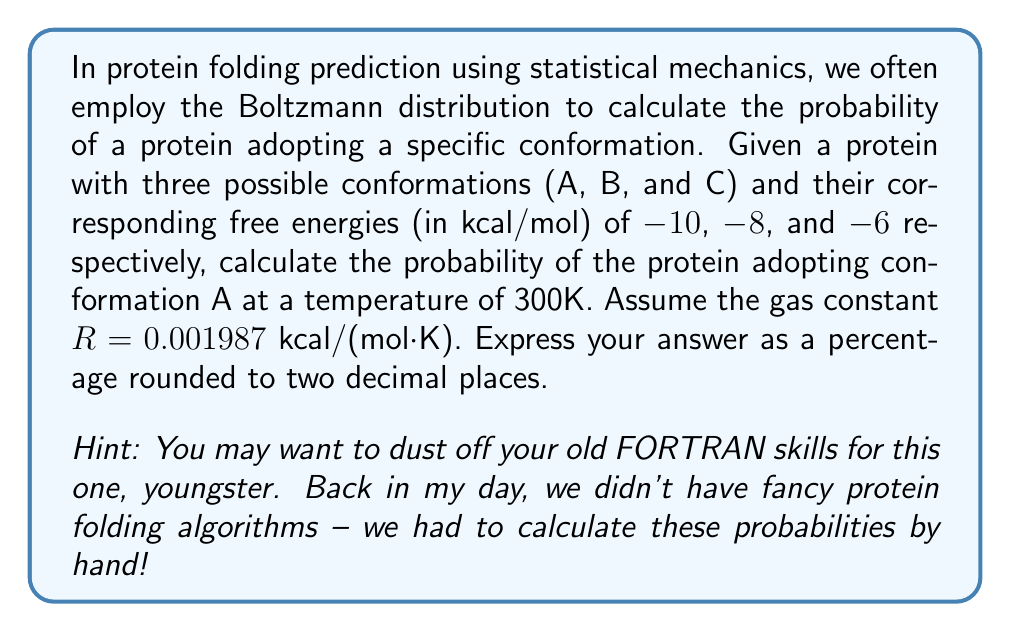Provide a solution to this math problem. Alright, let's break this down step-by-step, just like we used to do it in the good old days:

1) The Boltzmann distribution gives us the probability of a state i as:

   $$P_i = \frac{e^{-E_i/kT}}{\sum_j e^{-E_j/kT}}$$

   where $E_i$ is the energy of state i, k is the Boltzmann constant, and T is the temperature.

2) In our case, we're using free energies (G) instead of energies (E), and R (gas constant) instead of k. So our equation becomes:

   $$P_i = \frac{e^{-G_i/RT}}{\sum_j e^{-G_j/RT}}$$

3) Let's calculate the denominator first (the partition function):

   $$Z = e^{-G_A/RT} + e^{-G_B/RT} + e^{-G_C/RT}$$

4) Plugging in our values:
   
   $$Z = e^{10/(0.001987 \cdot 300)} + e^{8/(0.001987 \cdot 300)} + e^{6/(0.001987 \cdot 300)}$$
   
   $$Z = e^{16.76} + e^{13.41} + e^{10.06}$$
   
   $$Z = 1.90 \times 10^7 + 6.69 \times 10^5 + 2.35 \times 10^4$$
   
   $$Z = 1.97 \times 10^7$$

5) Now, let's calculate the probability of conformation A:

   $$P_A = \frac{e^{10/(0.001987 \cdot 300)}}{1.97 \times 10^7}$$

   $$P_A = \frac{1.90 \times 10^7}{1.97 \times 10^7} = 0.9644$$

6) Converting to a percentage:

   $$P_A = 0.9644 \times 100\% = 96.44\%$$

Thus, the probability of the protein adopting conformation A is 96.44%.
Answer: 96.44% 